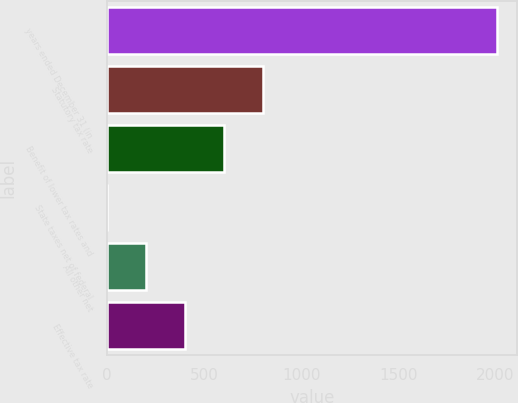Convert chart. <chart><loc_0><loc_0><loc_500><loc_500><bar_chart><fcel>years ended December 31 (in<fcel>Statutory tax rate<fcel>Benefit of lower tax rates and<fcel>State taxes net of federal<fcel>All other net<fcel>Effective tax rate<nl><fcel>2010<fcel>804.12<fcel>603.14<fcel>0.2<fcel>201.18<fcel>402.16<nl></chart> 